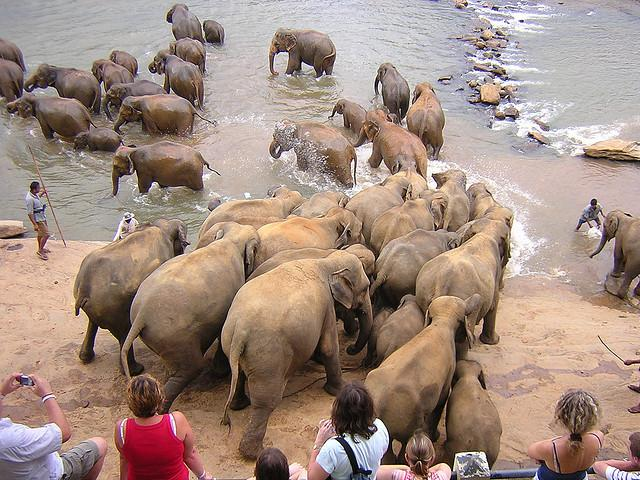Why is the man holding a camera? taking pictures 